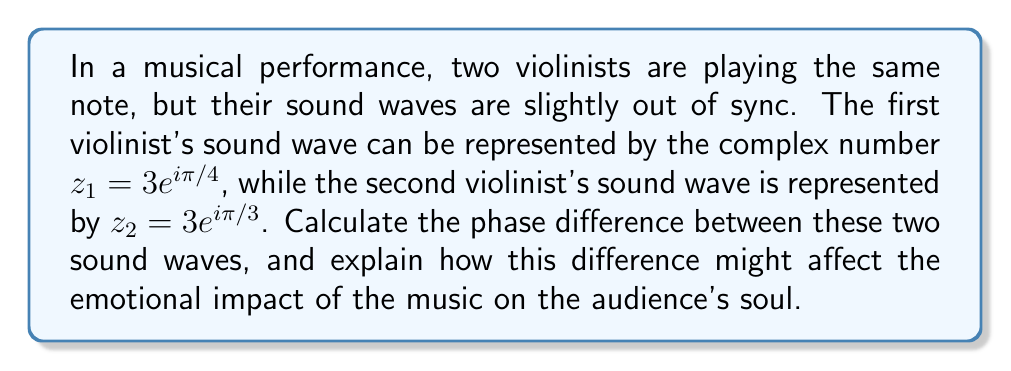Show me your answer to this math problem. To determine the phase difference between the two sound waves, we need to follow these steps:

1) The complex numbers representing the sound waves are given in polar form:
   $z_1 = 3e^{i\pi/4}$ and $z_2 = 3e^{i\pi/3}$

2) The phase of a complex number in the form $re^{i\theta}$ is given by $\theta$.

3) For $z_1$, the phase is $\theta_1 = \pi/4$ radians.
   For $z_2$, the phase is $\theta_2 = \pi/3$ radians.

4) The phase difference is the absolute value of the difference between these phases:
   $$\text{Phase difference} = |\theta_2 - \theta_1| = |\pi/3 - \pi/4|$$

5) Simplifying:
   $$|\pi/3 - \pi/4| = |\frac{4\pi}{12} - \frac{3\pi}{12}| = |\frac{\pi}{12}|$$

6) Therefore, the phase difference is $\pi/12$ radians.

7) To convert to degrees:
   $$\frac{\pi}{12} \cdot \frac{180°}{\pi} = 15°$$

This phase difference of 15° creates a slight delay between the two sound waves, which can produce a richer, more complex sound. In music, this can evoke a sense of depth and dimension, potentially stirring deeper emotions in the audience. The subtle interplay between the slightly out-of-sync waves can create a more vibrant and alive feeling in the music, touching the soul in ways that perfectly synchronized sounds might not.
Answer: $15°$ or $\frac{\pi}{12}$ radians 